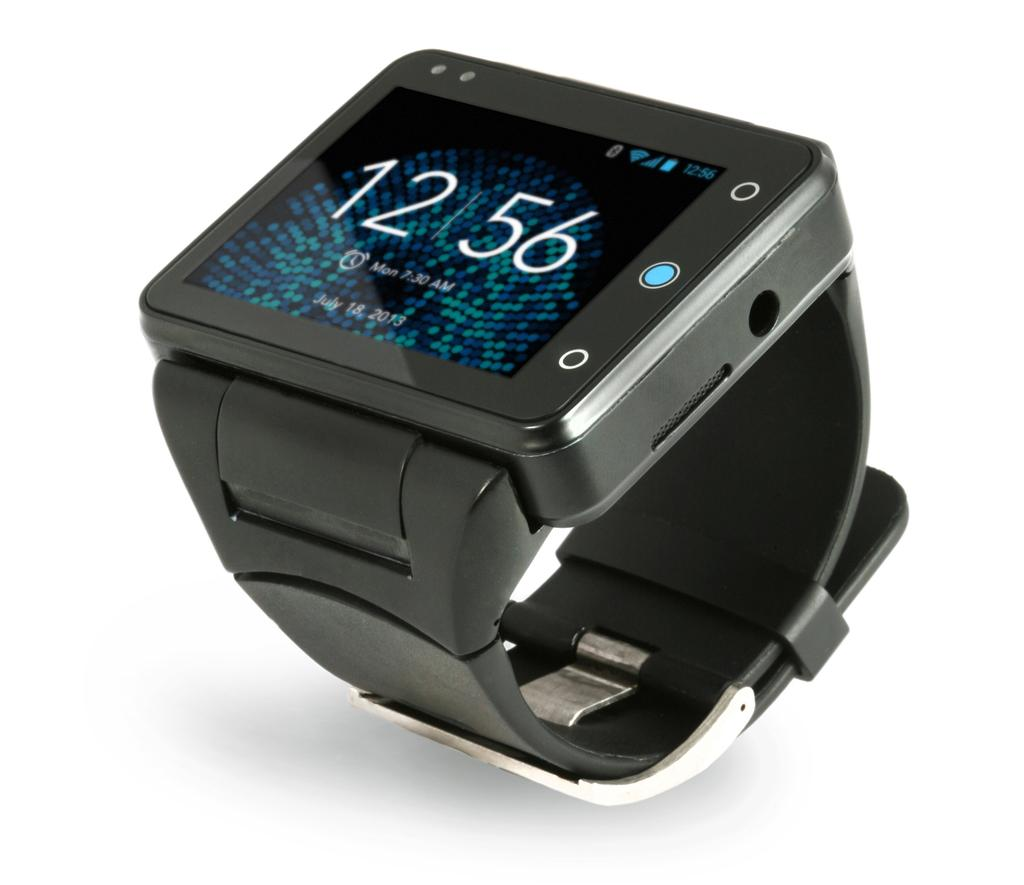<image>
Present a compact description of the photo's key features. A smart watch shows that the current time is 12:56. 